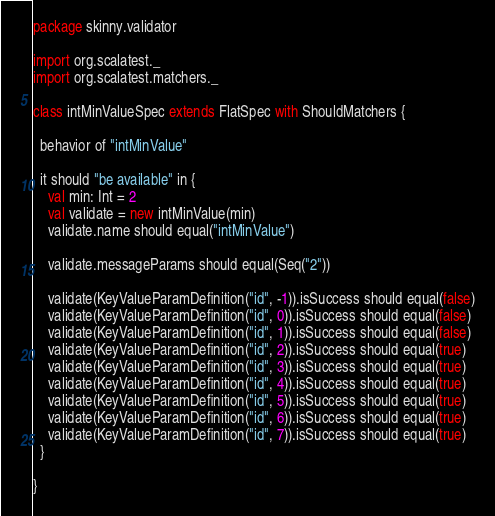Convert code to text. <code><loc_0><loc_0><loc_500><loc_500><_Scala_>package skinny.validator

import org.scalatest._
import org.scalatest.matchers._

class intMinValueSpec extends FlatSpec with ShouldMatchers {

  behavior of "intMinValue"

  it should "be available" in {
    val min: Int = 2
    val validate = new intMinValue(min)
    validate.name should equal("intMinValue")

    validate.messageParams should equal(Seq("2"))

    validate(KeyValueParamDefinition("id", -1)).isSuccess should equal(false)
    validate(KeyValueParamDefinition("id", 0)).isSuccess should equal(false)
    validate(KeyValueParamDefinition("id", 1)).isSuccess should equal(false)
    validate(KeyValueParamDefinition("id", 2)).isSuccess should equal(true)
    validate(KeyValueParamDefinition("id", 3)).isSuccess should equal(true)
    validate(KeyValueParamDefinition("id", 4)).isSuccess should equal(true)
    validate(KeyValueParamDefinition("id", 5)).isSuccess should equal(true)
    validate(KeyValueParamDefinition("id", 6)).isSuccess should equal(true)
    validate(KeyValueParamDefinition("id", 7)).isSuccess should equal(true)
  }

}
</code> 